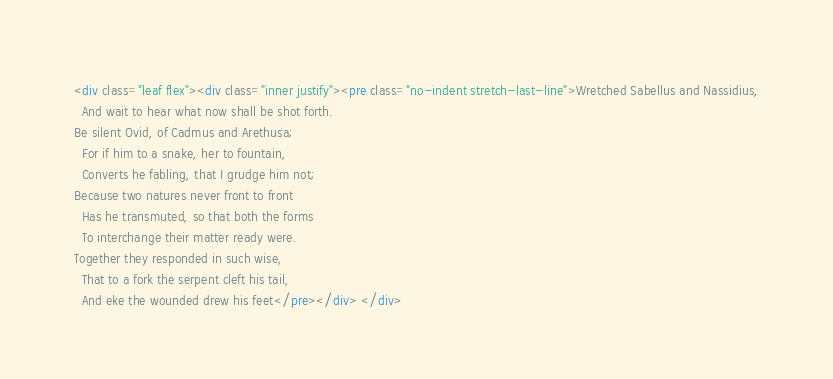<code> <loc_0><loc_0><loc_500><loc_500><_HTML_><div class="leaf flex"><div class="inner justify"><pre class="no-indent stretch-last-line">Wretched Sabellus and Nassidius,
  And wait to hear what now shall be shot forth.
Be silent Ovid, of Cadmus and Arethusa;
  For if him to a snake, her to fountain,
  Converts he fabling, that I grudge him not;
Because two natures never front to front
  Has he transmuted, so that both the forms
  To interchange their matter ready were.
Together they responded in such wise,
  That to a fork the serpent cleft his tail,
  And eke the wounded drew his feet</pre></div> </div></code> 